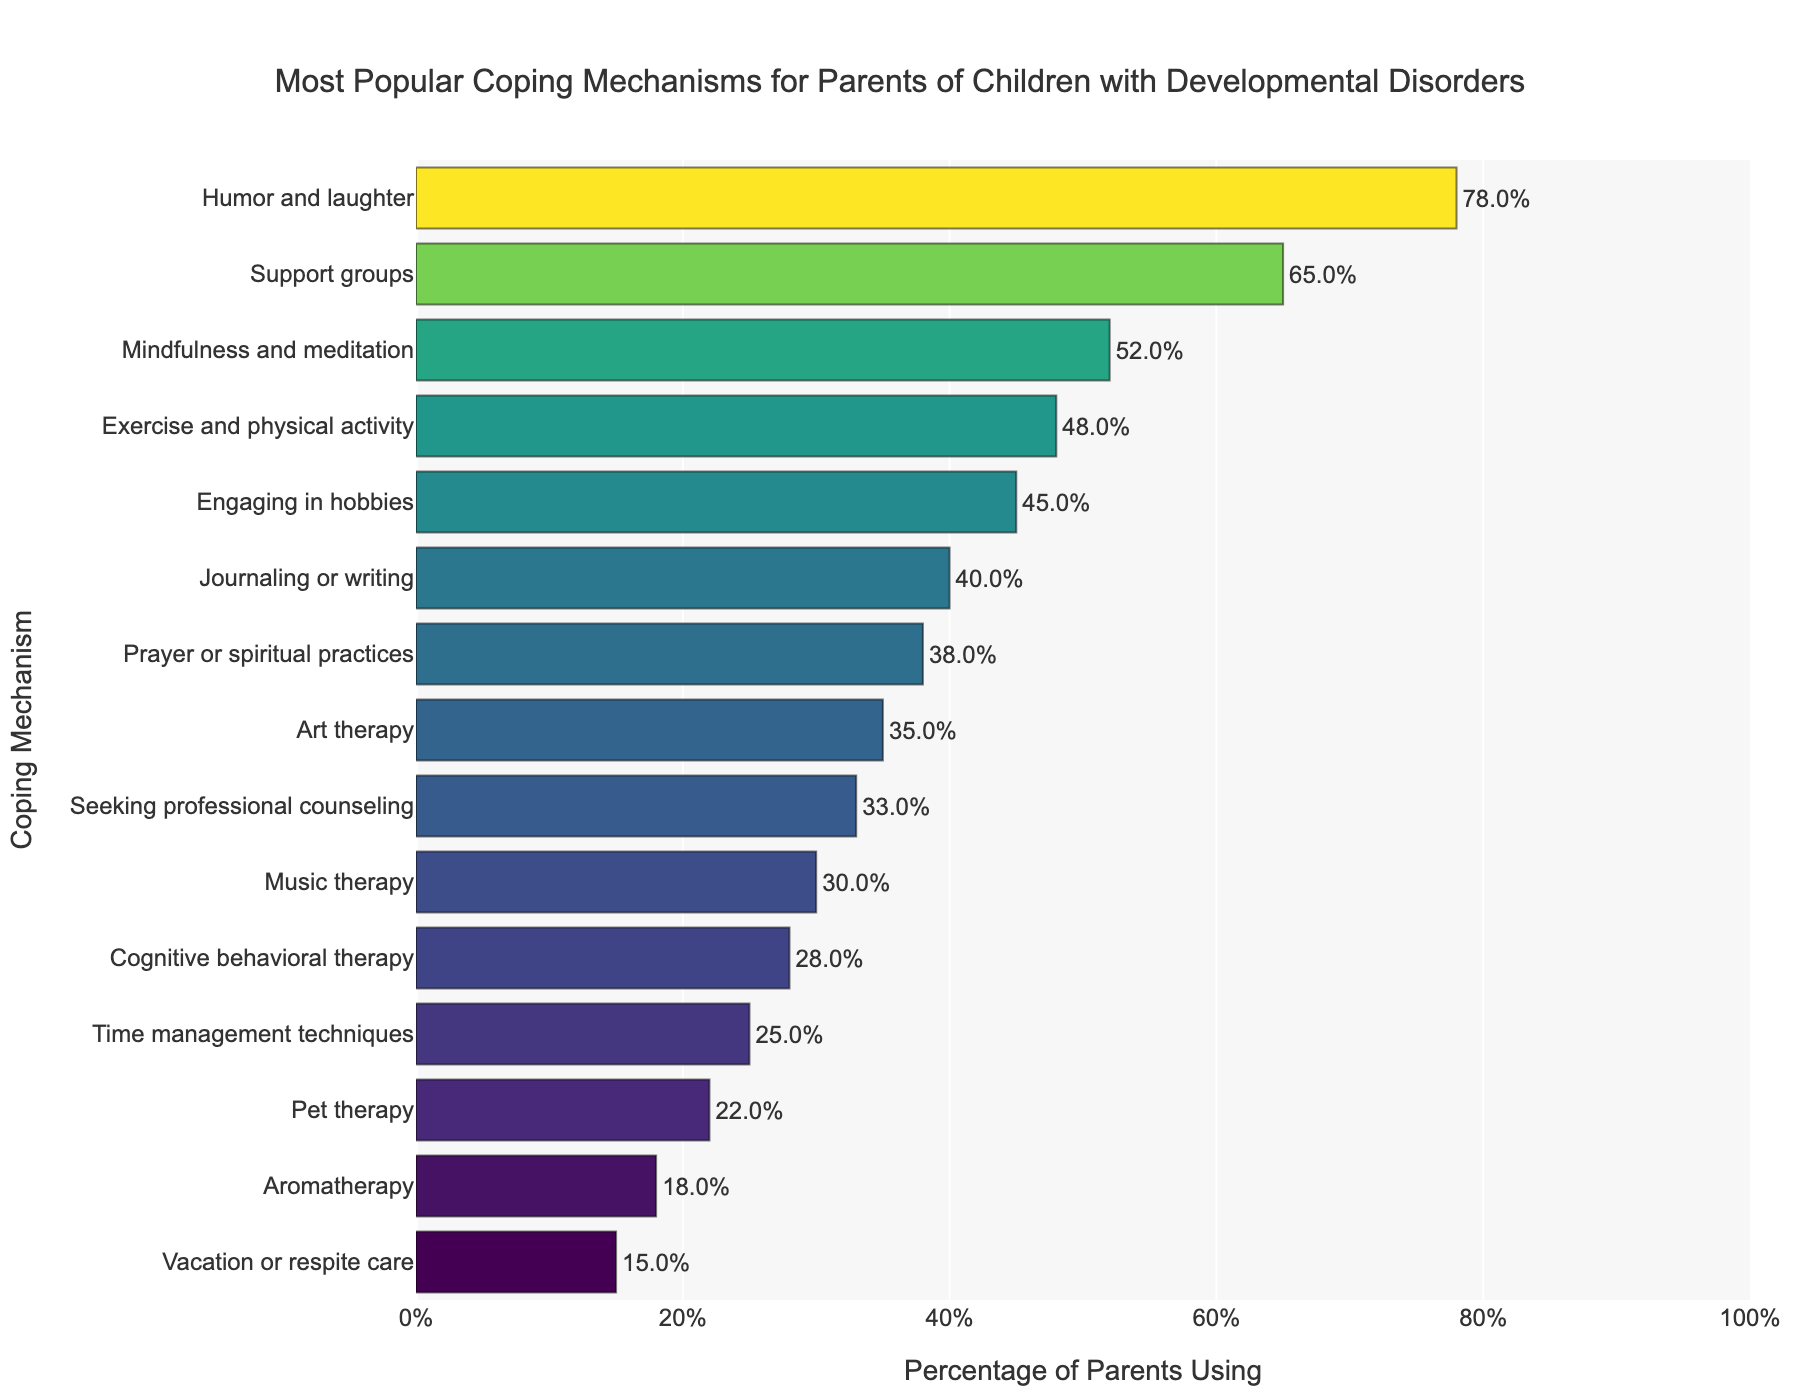Which coping mechanism is the most popular among parents of children with developmental disorders? The most popular coping mechanism can be identified by looking for the bar with the highest percentage. In this case, "Humor and laughter" has the highest percentage at 78%.
Answer: Humor and laughter Which coping mechanism is the least popular among parents of children with developmental disorders? The least popular coping mechanism can be identified by looking for the bar with the lowest percentage. In this case, "Vacation or respite care" has the lowest percentage at 15%.
Answer: Vacation or respite care How many coping mechanisms are used by at least 50% of parents? To find the number of coping mechanisms used by at least 50% of parents, count the bars with percentages 50% or greater. "Humor and laughter," "Support groups," and "Mindfulness and meditation" are the mechanisms that meet this criterion.
Answer: 3 What is the percentage difference between the most preferred and least preferred coping mechanisms? To find this, subtract the percentage of the least preferred mechanism (15% for "Vacation or respite care") from the most preferred mechanism (78% for "Humor and laughter"). The difference is 78% - 15% = 63%.
Answer: 63% Which three coping mechanisms have the closest percentages? By comparing the percentages, it is observed that "Music therapy," "Cognitive behavioral therapy," and "Pet therapy" have close percentages at 30%, 28%, and 22% respectively.
Answer: Music therapy, Cognitive behavioral therapy, Pet therapy Are there more coping mechanisms used by over 30% of parents or by under 30% of parents? Count the coping mechanisms with percentages over 30%: 9 mechanisms. Count the coping mechanisms with percentages under 30%: 6 mechanisms. Since 9 > 6, there are more coping mechanisms used by over 30% of parents.
Answer: Over 30% What percentage of parents use both "Support groups" and "Prayer or spiritual practices"? This is a compositional question. From the figure, "Support groups" is at 65% and "Prayer or spiritual practices" is at 38%. Although it is not stated that the same parents use both, the direct lookup suggests individual usages.
Answer: Not Determinable Directly Which is more popular among parents: "Exercise and physical activity" or "Engaging in hobbies"? Compare the percentages of these two coping mechanisms. "Exercise and physical activity" is at 48%, while "Engaging in hobbies" is at 45%, making "Exercise and physical activity" more popular.
Answer: Exercise and physical activity By how much does the usage of "Journaling or writing" exceed that of "Pet therapy"? Subtract the percentage of "Pet therapy" (22%) from "Journaling or writing" (40%). The difference is 40% - 22% = 18%.
Answer: 18% Which coping mechanisms fall in the range of 30% to 40% usage by parents? Identify the bars within the 30%-40% range. These are "Music therapy" (30%), "Prayer or spiritual practices" (38%), and "Seeking professional counseling" (33%).
Answer: Music therapy, Prayer or spiritual practices, Seeking professional counseling 